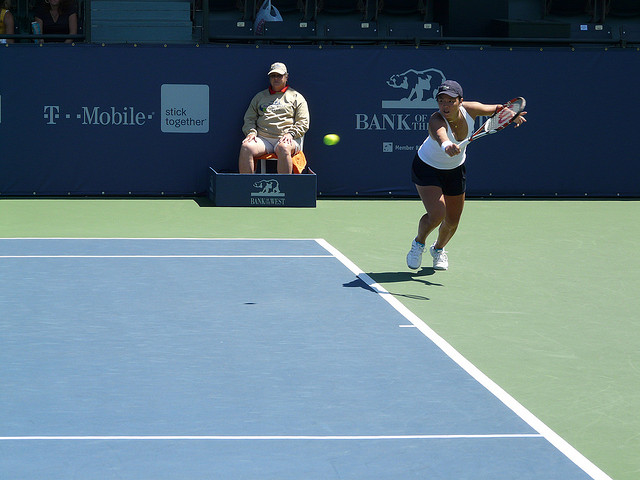<image>What clothing label is a sponsor of this event? I don't know which clothing label is a sponsor of this event. It could be 'nike', 'champion', 'wilson', or 'adidas'. What clothing label is a sponsor of this event? It is unanswerable what clothing label is a sponsor of this event. There are multiple possibilities such as 'nike', 'champion', 'wilson', or 'adidas'. 